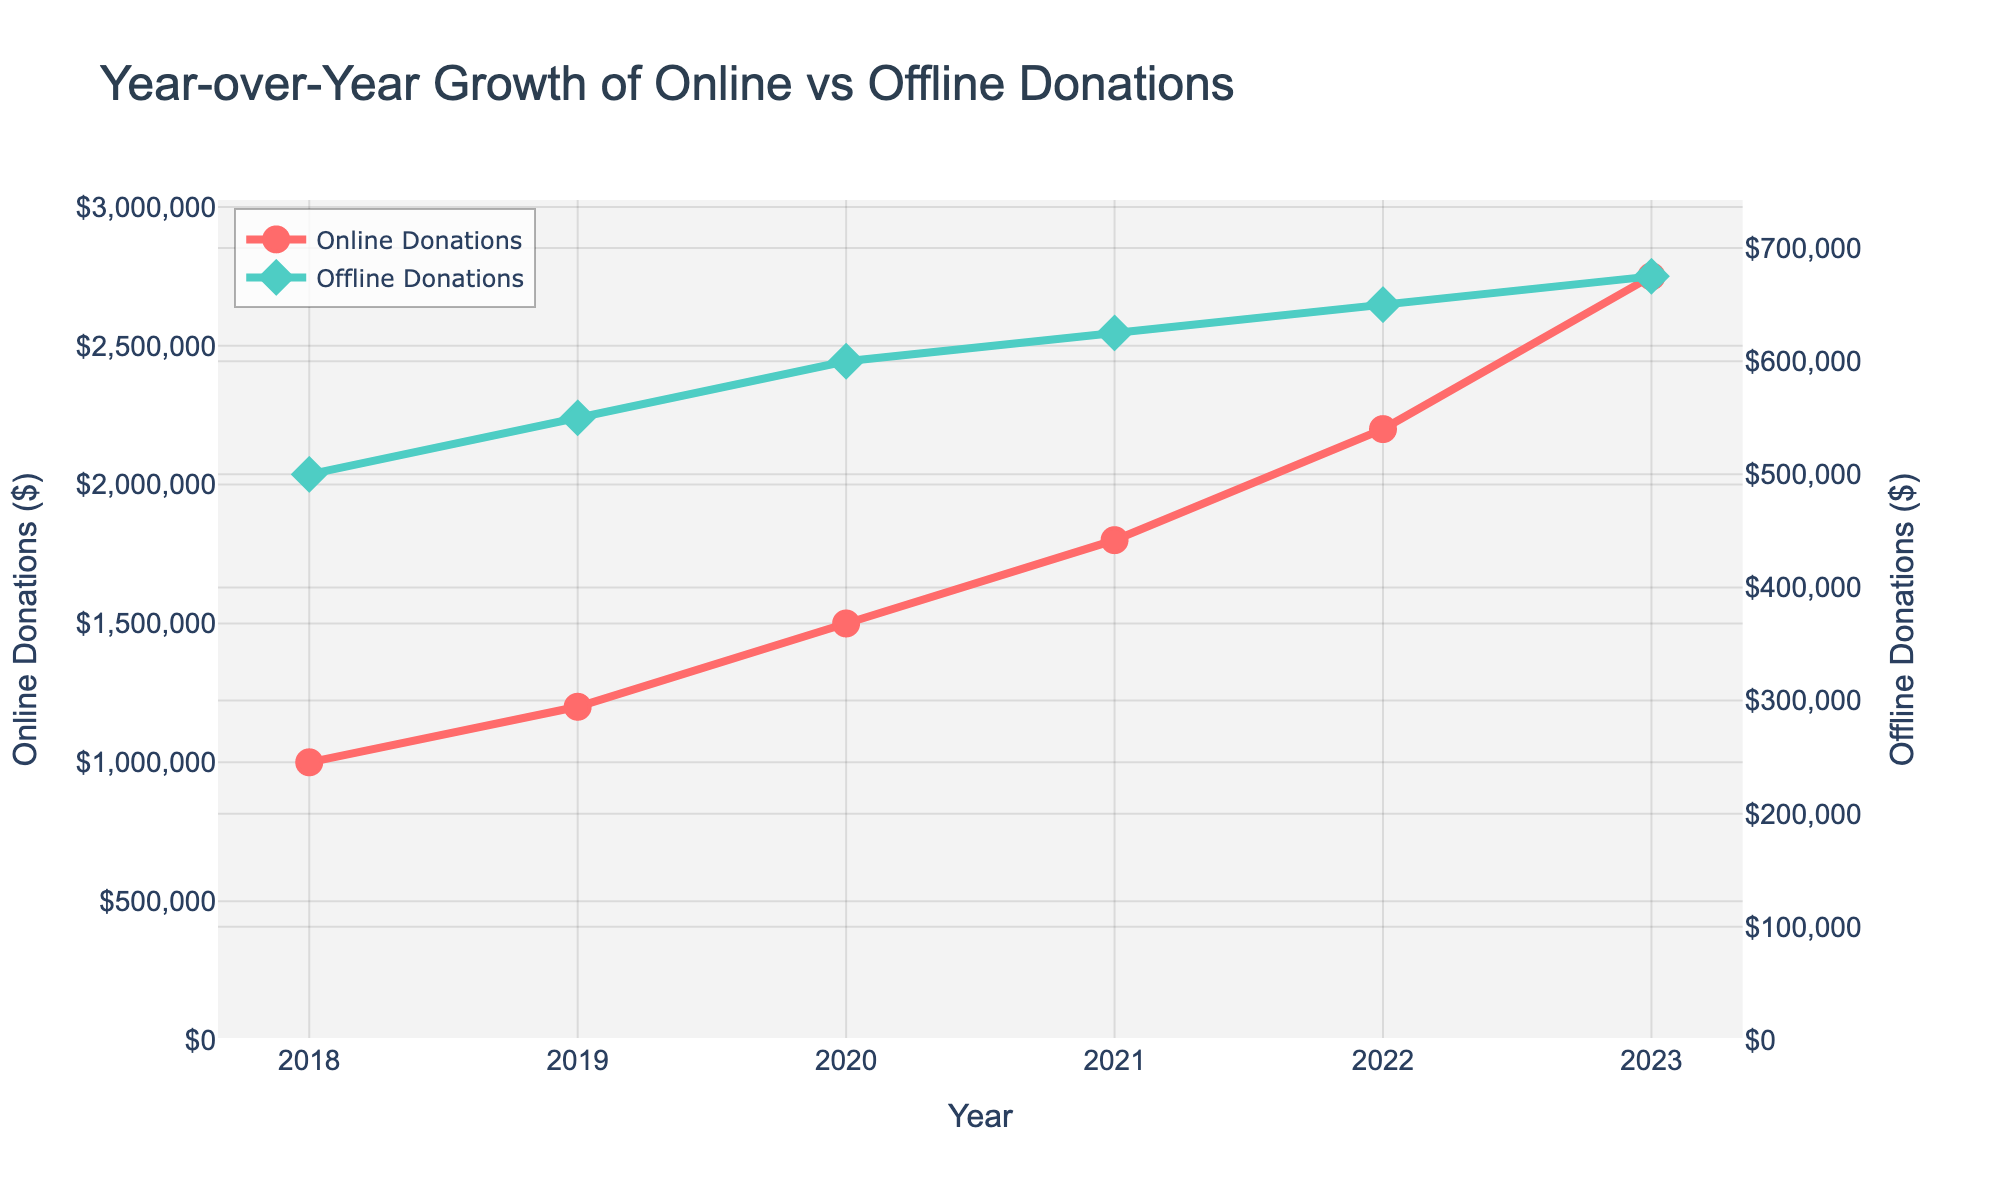what is the title of the plot? The title of the plot should be located at the top center and is meant to give an overview of what the plot represents.
Answer: Year-over-Year Growth of Online vs Offline Donations How many years of data are shown in the plot? Count the number of distinct years displayed on the x-axis of the plot.
Answer: 6 What color is used to represent online donations? Look at the color of the line and the markers corresponding to the label "Online Donations" in the legend.
Answer: Red What is the highest value for offline donations in the dataset? Look at the y-axis corresponding to offline donations and identify the highest point on the line representing offline donations.
Answer: $675,000 By how much did online donations increase from 2022 to 2023? Find the value of online donations for 2022 and 2023, and subtract the former from the latter. The online donations in 2022 were $2,200,000 and in 2023 were $2,750,000. So, the difference is $2,750,000 - $2,200,000.
Answer: $550,000 In which year did online donations first exceed offline donations by at least $1,000,000? Compare the difference between online and offline donations for each year until the difference is at least $1,000,000. In 2022, online donations were $2,200,000 and offline were $650,000, so $2,200,000 - $650,000 = $1,550,000.
Answer: 2022 What was the percentage increase in online donations from 2021 to 2022? Determine the value of online donations in 2021 and 2022. Then, use the formula: ((2022 value - 2021 value) / 2021 value) * 100. So, ((2,200,000 - 1,800,000) / 1,800,000) * 100.
Answer: 22.2% What can be inferred about the trend in offline donations from 2018 to 2023? Look at the overall direction of the line representing offline donations between 2018 and 2023 to determine the trend. The line indicates a gradual upward trend.
Answer: Gradual increase Which year had the highest growth rate in online donations compared to the previous year? Calculate the growth rate for each year by taking the difference from the previous year and dividing by the previous year's value, then look for the highest rate. From 2022 to 2023, the growth rate is ((2,750,000 - 2,200,000) / 2,200,000) = 0.25 = 25%.
Answer: 2023 